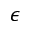Convert formula to latex. <formula><loc_0><loc_0><loc_500><loc_500>{ \epsilon }</formula> 